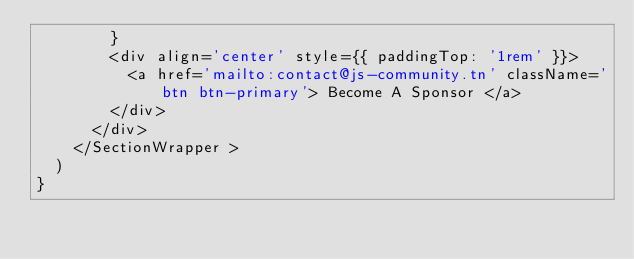<code> <loc_0><loc_0><loc_500><loc_500><_JavaScript_>        }
        <div align='center' style={{ paddingTop: '1rem' }}>
          <a href='mailto:contact@js-community.tn' className='btn btn-primary'> Become A Sponsor </a>
        </div>
      </div>
    </SectionWrapper >
  )
}
</code> 